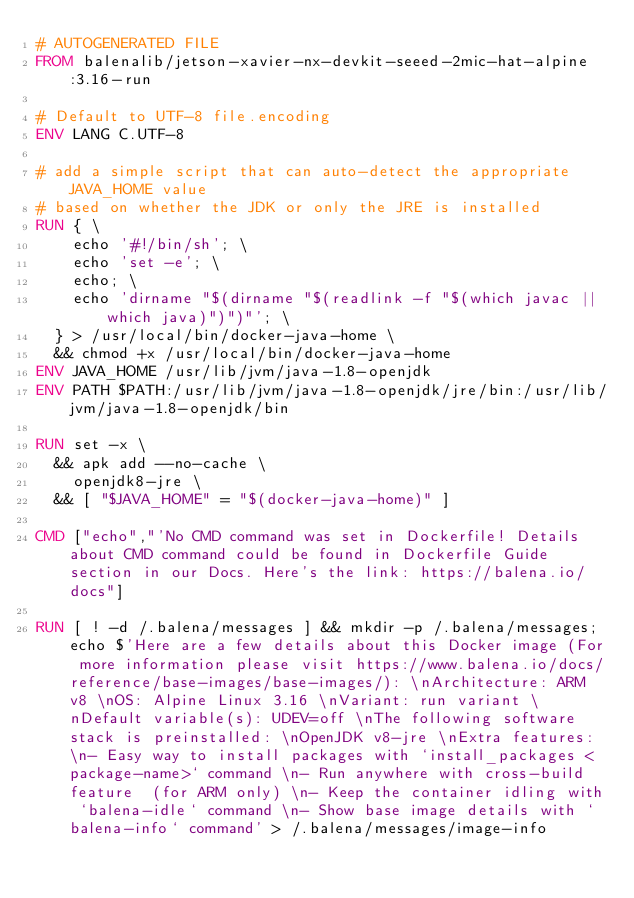Convert code to text. <code><loc_0><loc_0><loc_500><loc_500><_Dockerfile_># AUTOGENERATED FILE
FROM balenalib/jetson-xavier-nx-devkit-seeed-2mic-hat-alpine:3.16-run

# Default to UTF-8 file.encoding
ENV LANG C.UTF-8

# add a simple script that can auto-detect the appropriate JAVA_HOME value
# based on whether the JDK or only the JRE is installed
RUN { \
		echo '#!/bin/sh'; \
		echo 'set -e'; \
		echo; \
		echo 'dirname "$(dirname "$(readlink -f "$(which javac || which java)")")"'; \
	} > /usr/local/bin/docker-java-home \
	&& chmod +x /usr/local/bin/docker-java-home
ENV JAVA_HOME /usr/lib/jvm/java-1.8-openjdk
ENV PATH $PATH:/usr/lib/jvm/java-1.8-openjdk/jre/bin:/usr/lib/jvm/java-1.8-openjdk/bin

RUN set -x \
	&& apk add --no-cache \
		openjdk8-jre \
	&& [ "$JAVA_HOME" = "$(docker-java-home)" ]

CMD ["echo","'No CMD command was set in Dockerfile! Details about CMD command could be found in Dockerfile Guide section in our Docs. Here's the link: https://balena.io/docs"]

RUN [ ! -d /.balena/messages ] && mkdir -p /.balena/messages; echo $'Here are a few details about this Docker image (For more information please visit https://www.balena.io/docs/reference/base-images/base-images/): \nArchitecture: ARM v8 \nOS: Alpine Linux 3.16 \nVariant: run variant \nDefault variable(s): UDEV=off \nThe following software stack is preinstalled: \nOpenJDK v8-jre \nExtra features: \n- Easy way to install packages with `install_packages <package-name>` command \n- Run anywhere with cross-build feature  (for ARM only) \n- Keep the container idling with `balena-idle` command \n- Show base image details with `balena-info` command' > /.balena/messages/image-info</code> 